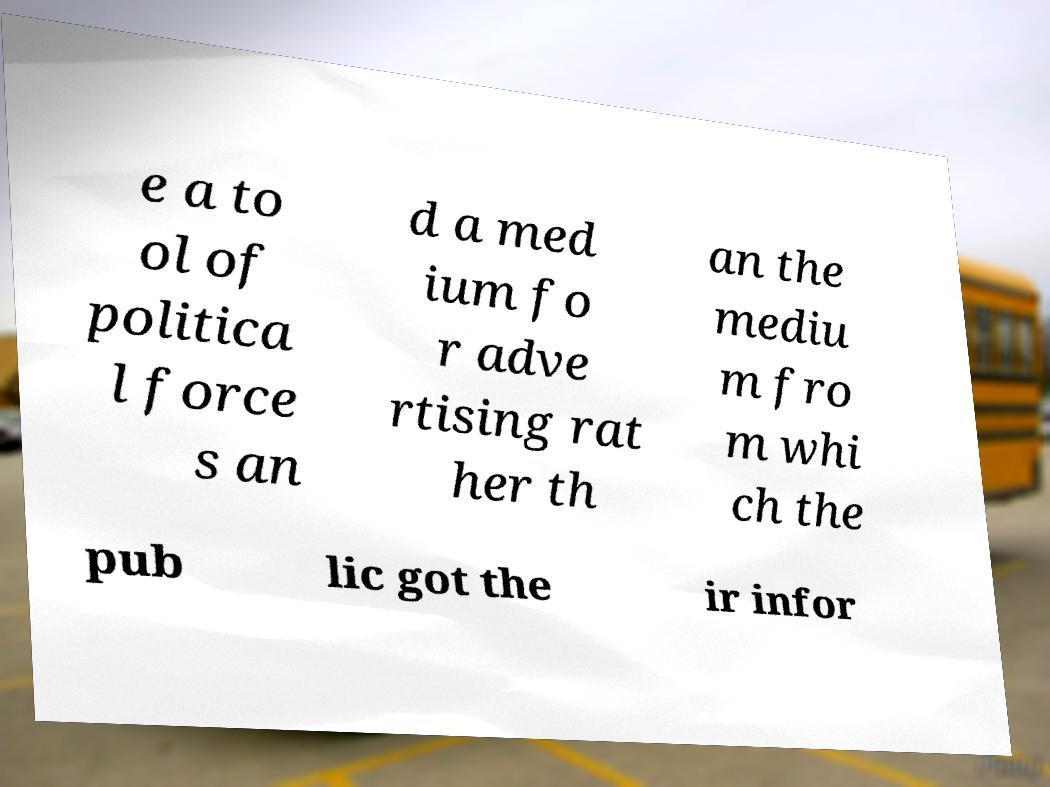Could you extract and type out the text from this image? e a to ol of politica l force s an d a med ium fo r adve rtising rat her th an the mediu m fro m whi ch the pub lic got the ir infor 